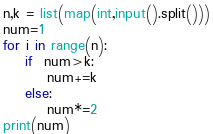<code> <loc_0><loc_0><loc_500><loc_500><_Python_>n,k = list(map(int,input().split()))
num=1
for i in range(n):
    if  num>k:
        num+=k
    else:
        num*=2
print(num)</code> 